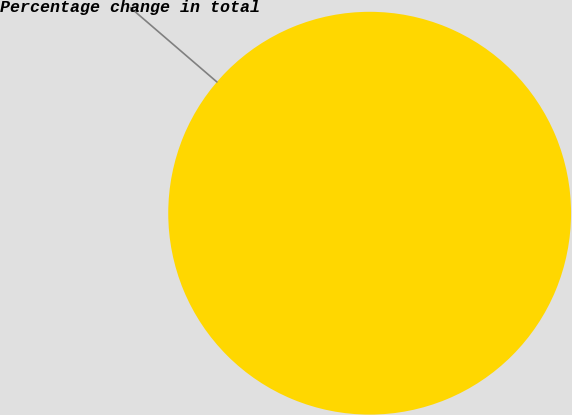Convert chart. <chart><loc_0><loc_0><loc_500><loc_500><pie_chart><fcel>Percentage change in total<nl><fcel>100.0%<nl></chart> 